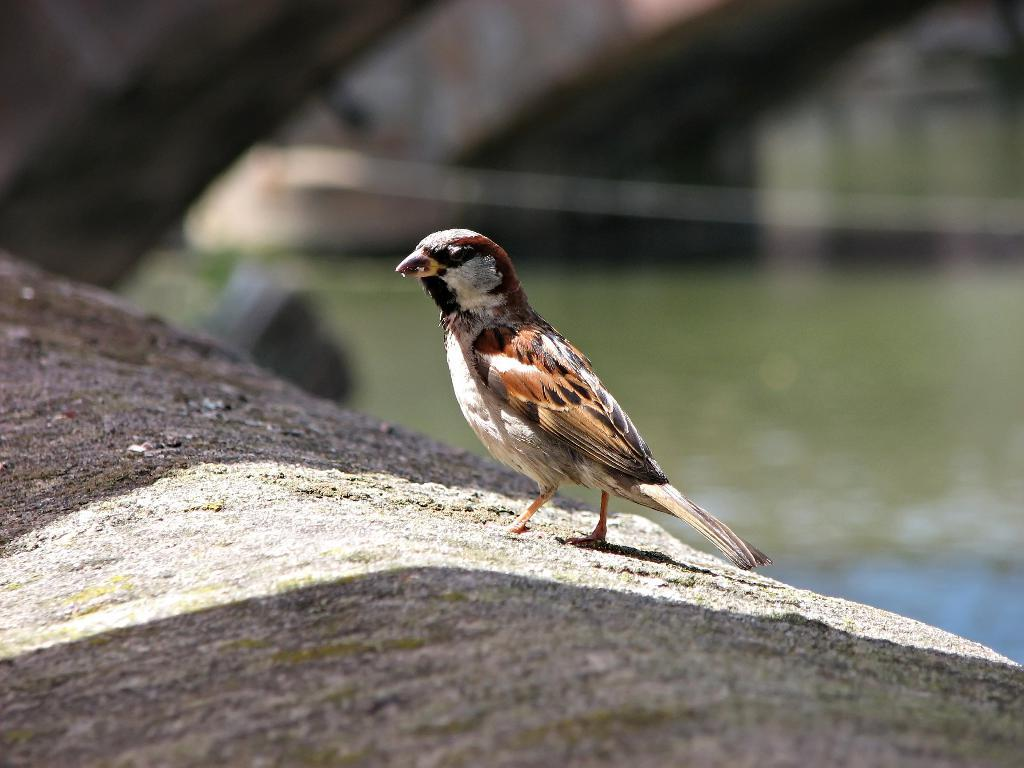What type of animal can be seen in the image? There is a bird in the image. Where is the bird located? The bird is on a rock. What can be seen in the background of the image? There is water visible in the background of the image. What is the bird's annual income in the image? There is no information about the bird's income in the image, as birds do not have incomes. 